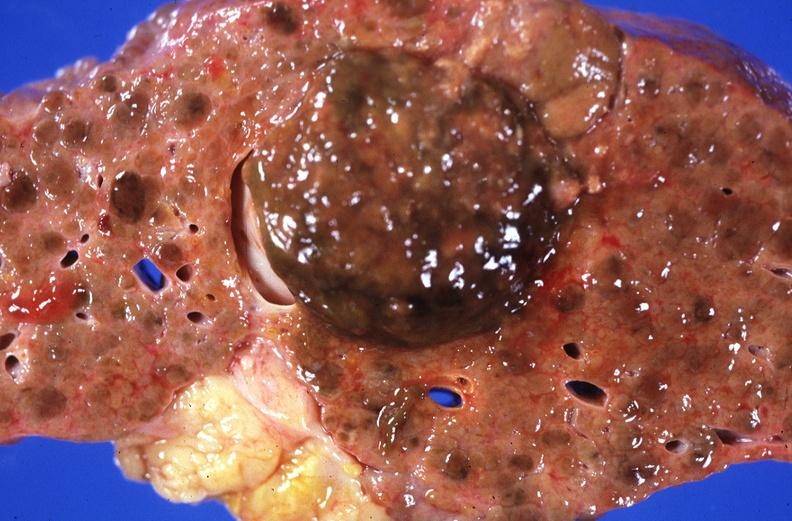s liver present?
Answer the question using a single word or phrase. Yes 